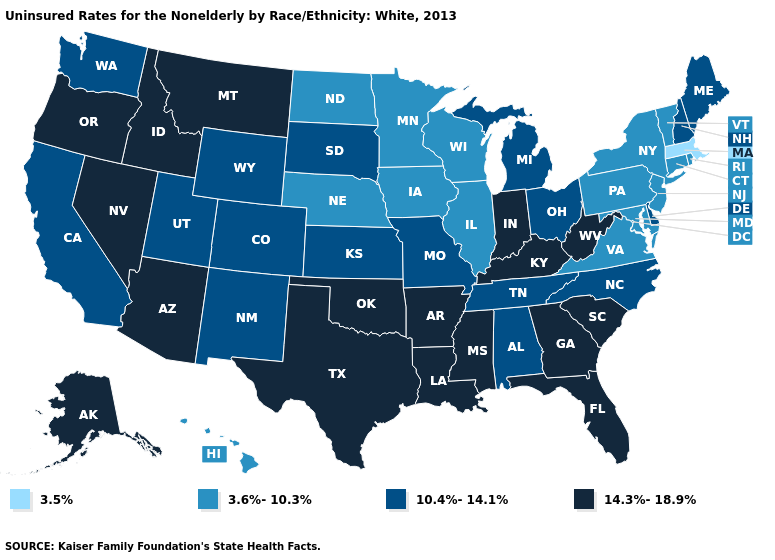What is the value of California?
Be succinct. 10.4%-14.1%. Name the states that have a value in the range 3.6%-10.3%?
Be succinct. Connecticut, Hawaii, Illinois, Iowa, Maryland, Minnesota, Nebraska, New Jersey, New York, North Dakota, Pennsylvania, Rhode Island, Vermont, Virginia, Wisconsin. Does the first symbol in the legend represent the smallest category?
Concise answer only. Yes. Does Illinois have the lowest value in the USA?
Write a very short answer. No. Does the first symbol in the legend represent the smallest category?
Answer briefly. Yes. Name the states that have a value in the range 14.3%-18.9%?
Give a very brief answer. Alaska, Arizona, Arkansas, Florida, Georgia, Idaho, Indiana, Kentucky, Louisiana, Mississippi, Montana, Nevada, Oklahoma, Oregon, South Carolina, Texas, West Virginia. Is the legend a continuous bar?
Be succinct. No. What is the value of Delaware?
Short answer required. 10.4%-14.1%. Does Wisconsin have a lower value than Minnesota?
Write a very short answer. No. Is the legend a continuous bar?
Quick response, please. No. What is the highest value in the USA?
Short answer required. 14.3%-18.9%. Does Massachusetts have the lowest value in the USA?
Give a very brief answer. Yes. Does the map have missing data?
Short answer required. No. Among the states that border Washington , which have the highest value?
Be succinct. Idaho, Oregon. What is the highest value in the MidWest ?
Concise answer only. 14.3%-18.9%. 